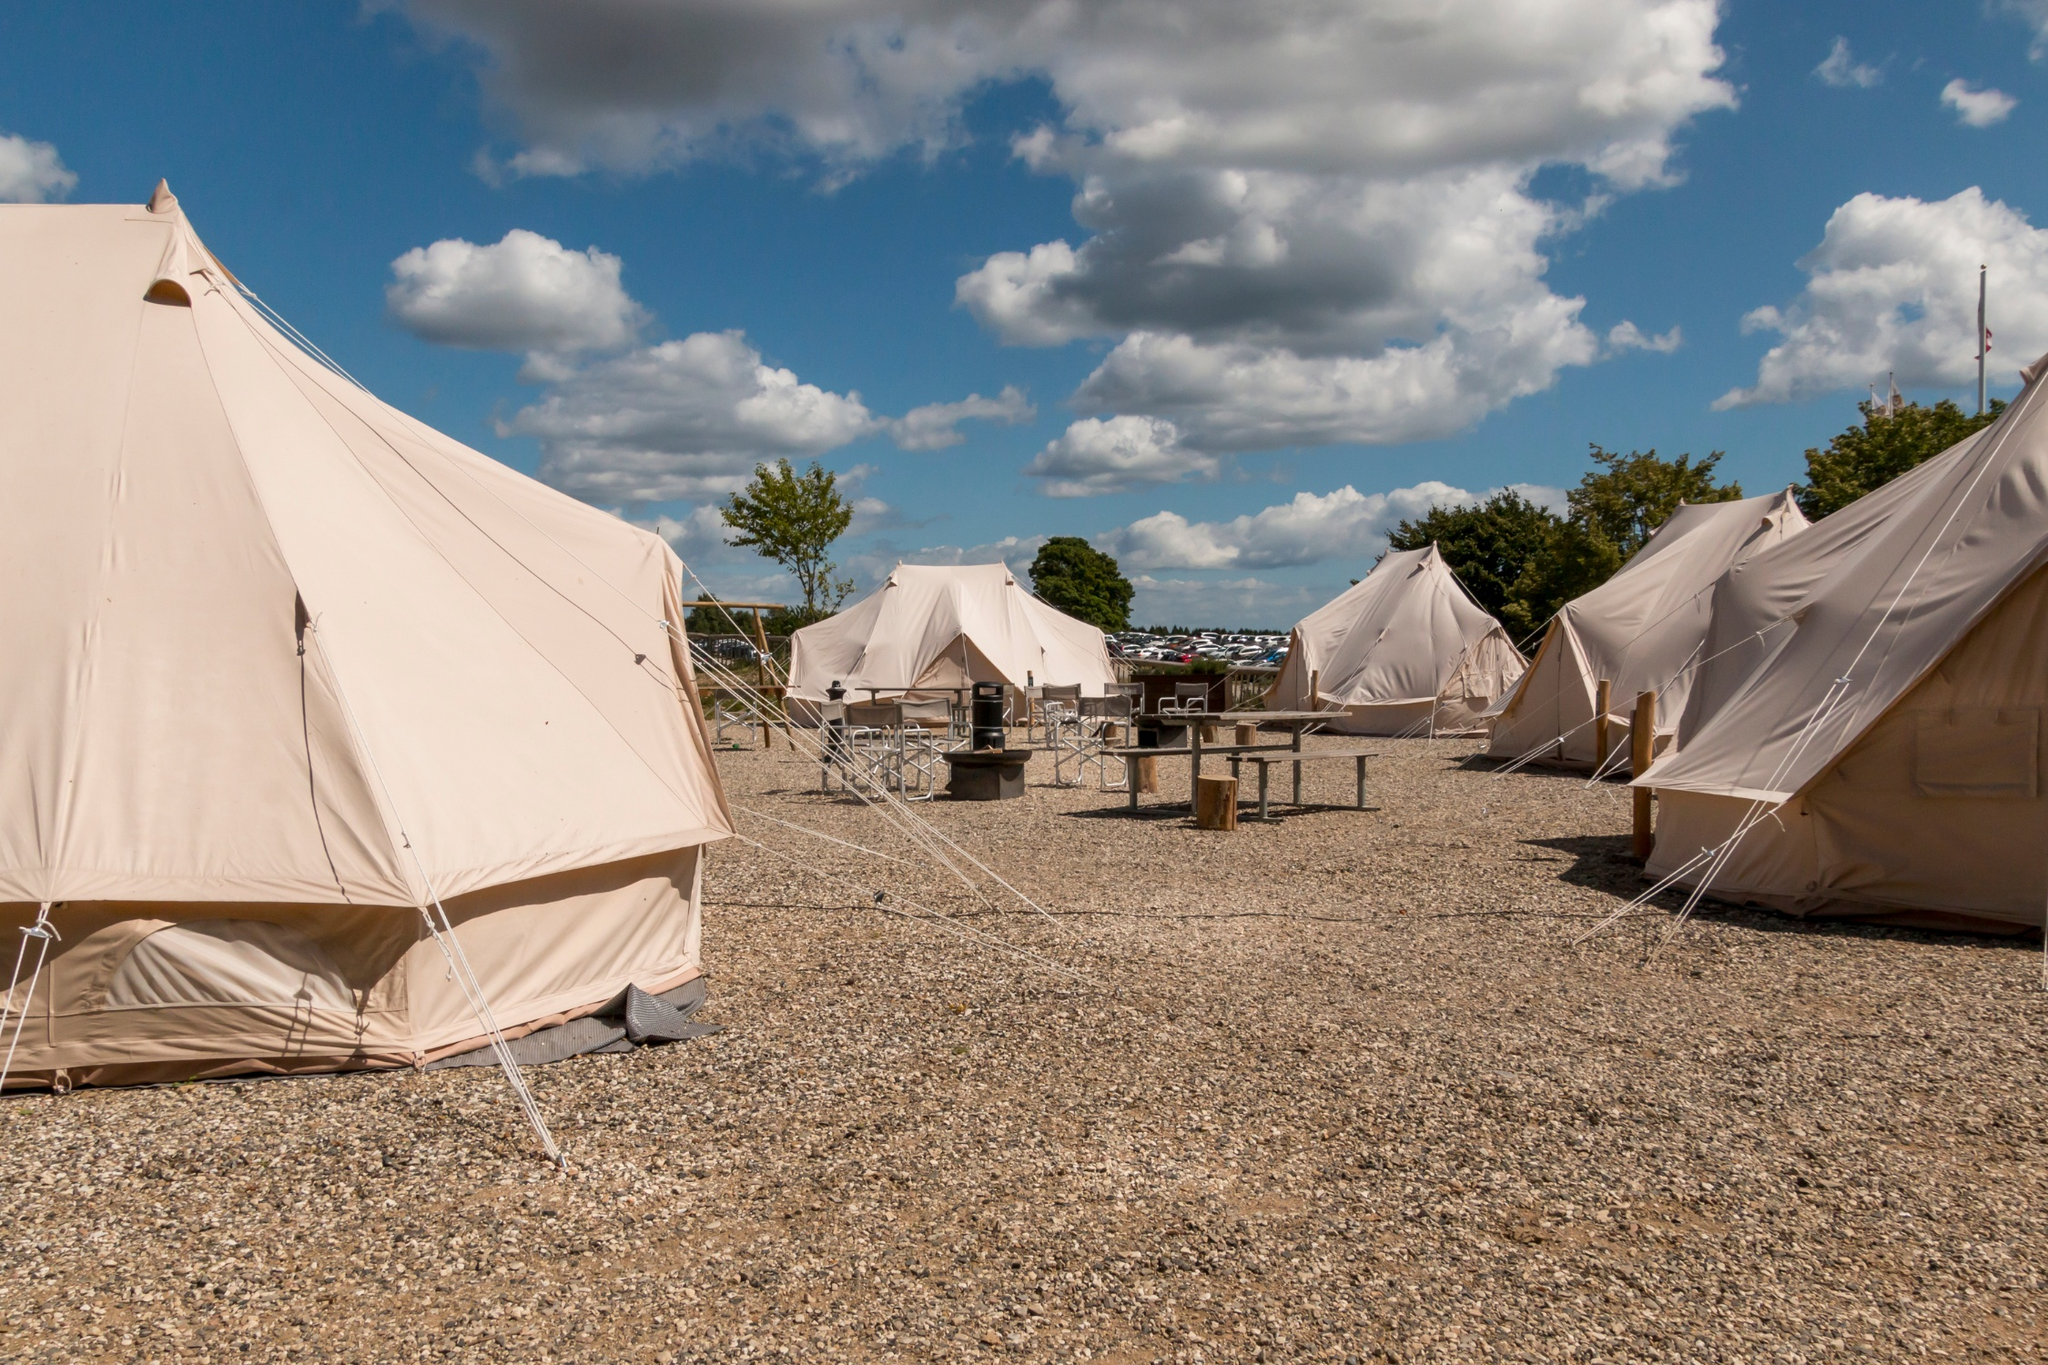Can you describe the weather in this image? The weather in this image appears to be delightful. The sky is a vibrant blue, adorned with scattered fluffy white clouds. The clouds suggest a partly cloudy day, but the overall atmosphere seems bright and cheerful, indicating that it is likely a perfect day for outdoor activities. There doesn't seem to be any sign of inclement weather, making this an ideal time to enjoy the serenity of this campsite. What kind of activities do you think people might engage in at this campsite? Considering the serene backdrop and pleasant weather, campers could engage in a variety of activities. Daytime might include nature walks or hikes through the surrounding area, perhaps even guided tours to explore local wildlife and flora. The wooden table and benches in the middle suggest communal dining, where campers could share meals and stories. In the evening, people might gather around a campfire for songs, marshmallow roasting, or storytelling. This setting is perfect for both relaxation and enjoying the camaraderie of fellow campers. 